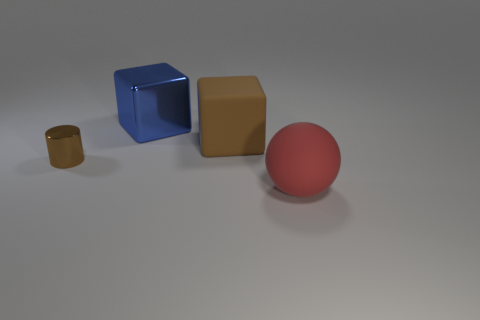Add 3 big purple balls. How many objects exist? 7 Subtract all brown blocks. How many blocks are left? 1 Subtract all brown cylinders. How many brown blocks are left? 1 Subtract all big spheres. Subtract all red matte objects. How many objects are left? 2 Add 1 big blue shiny cubes. How many big blue shiny cubes are left? 2 Add 4 big matte spheres. How many big matte spheres exist? 5 Subtract 0 blue spheres. How many objects are left? 4 Subtract all blue cubes. Subtract all purple spheres. How many cubes are left? 1 